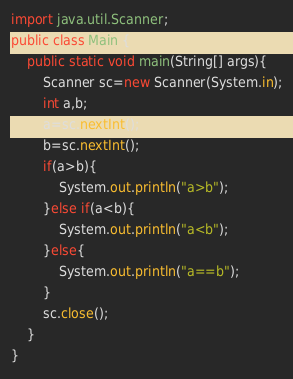Convert code to text. <code><loc_0><loc_0><loc_500><loc_500><_Java_>import java.util.Scanner;
public class Main {
	public static void main(String[] args){
		Scanner sc=new Scanner(System.in);
		int a,b;
		a=sc.nextInt();
		b=sc.nextInt();
		if(a>b){
			System.out.println("a>b");
		}else if(a<b){
			System.out.println("a<b");
		}else{
			System.out.println("a==b");
		}
		sc.close();
	}
}

</code> 